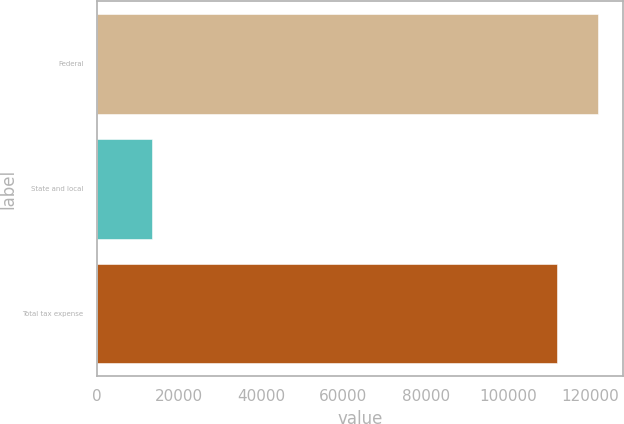<chart> <loc_0><loc_0><loc_500><loc_500><bar_chart><fcel>Federal<fcel>State and local<fcel>Total tax expense<nl><fcel>122017<fcel>13462<fcel>111913<nl></chart> 